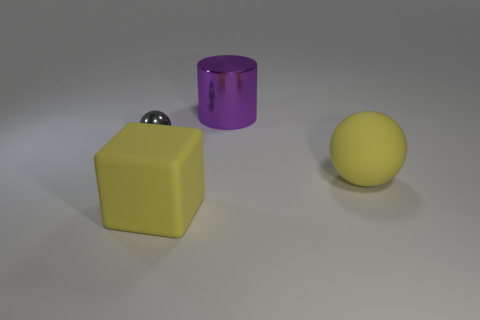Is there anything else that is the same size as the gray shiny object?
Your answer should be compact. No. Is the small gray thing the same shape as the large metal object?
Ensure brevity in your answer.  No. There is another yellow matte object that is the same shape as the tiny object; what is its size?
Ensure brevity in your answer.  Large. There is a gray shiny thing that is behind the yellow block; is it the same size as the purple object?
Provide a succinct answer. No. What size is the thing that is on the right side of the big yellow block and in front of the purple metal cylinder?
Your response must be concise. Large. What material is the object that is the same color as the big rubber sphere?
Provide a succinct answer. Rubber. How many spheres have the same color as the rubber cube?
Provide a succinct answer. 1. Are there the same number of yellow cubes that are behind the purple thing and big matte spheres?
Your answer should be very brief. No. What is the color of the large rubber sphere?
Provide a succinct answer. Yellow. What is the size of the thing that is made of the same material as the big purple cylinder?
Give a very brief answer. Small. 